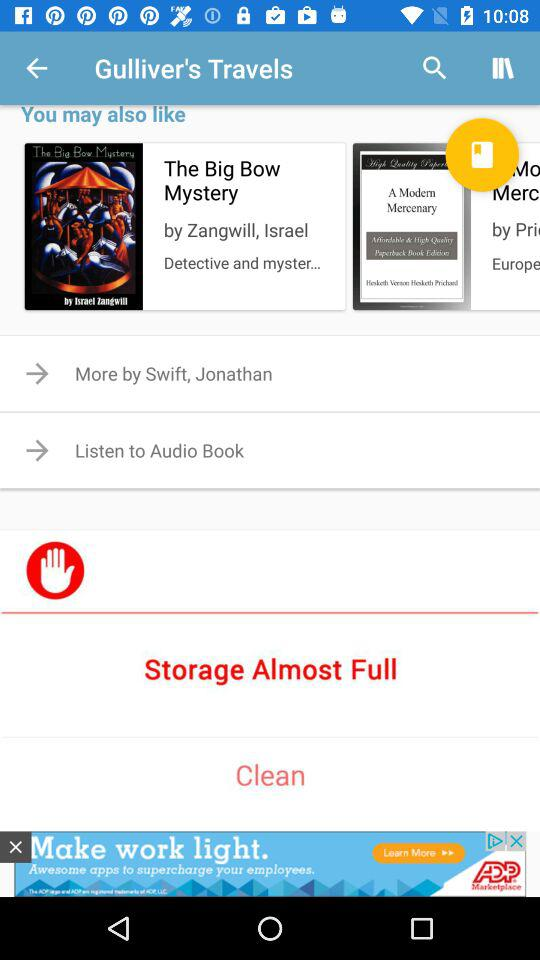Who is the author of "The Big Bow Mystery"? The author of "The Big Bow Mystery" is Zangwill. 